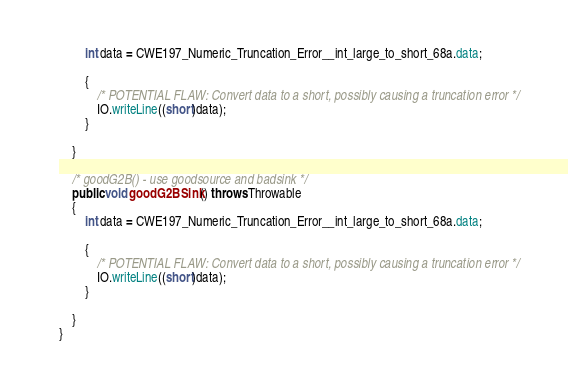Convert code to text. <code><loc_0><loc_0><loc_500><loc_500><_Java_>        int data = CWE197_Numeric_Truncation_Error__int_large_to_short_68a.data;

        {
            /* POTENTIAL FLAW: Convert data to a short, possibly causing a truncation error */
            IO.writeLine((short)data);
        }

    }

    /* goodG2B() - use goodsource and badsink */
    public void goodG2BSink() throws Throwable
    {
        int data = CWE197_Numeric_Truncation_Error__int_large_to_short_68a.data;

        {
            /* POTENTIAL FLAW: Convert data to a short, possibly causing a truncation error */
            IO.writeLine((short)data);
        }

    }
}
</code> 